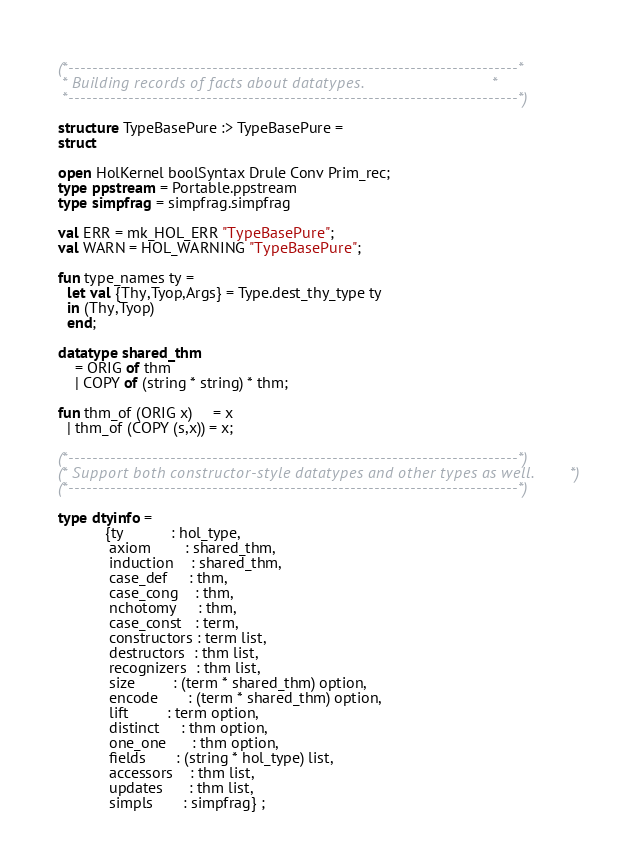Convert code to text. <code><loc_0><loc_0><loc_500><loc_500><_SML_>(*---------------------------------------------------------------------------*
 * Building records of facts about datatypes.                                *
 *---------------------------------------------------------------------------*)

structure TypeBasePure :> TypeBasePure =
struct

open HolKernel boolSyntax Drule Conv Prim_rec;
type ppstream = Portable.ppstream
type simpfrag = simpfrag.simpfrag

val ERR = mk_HOL_ERR "TypeBasePure";
val WARN = HOL_WARNING "TypeBasePure";

fun type_names ty =
  let val {Thy,Tyop,Args} = Type.dest_thy_type ty
  in (Thy,Tyop)
  end;

datatype shared_thm
    = ORIG of thm
    | COPY of (string * string) * thm;

fun thm_of (ORIG x)     = x
  | thm_of (COPY (s,x)) = x;

(*---------------------------------------------------------------------------*)
(* Support both constructor-style datatypes and other types as well.         *)
(*---------------------------------------------------------------------------*)

type dtyinfo =
           {ty           : hol_type,
            axiom        : shared_thm,
            induction    : shared_thm,
            case_def     : thm,
            case_cong    : thm,
            nchotomy     : thm,
            case_const   : term,
            constructors : term list,
            destructors  : thm list,
            recognizers  : thm list,
            size         : (term * shared_thm) option,
            encode       : (term * shared_thm) option,
            lift         : term option,
            distinct     : thm option,
            one_one      : thm option,
            fields       : (string * hol_type) list,
            accessors    : thm list,
            updates      : thm list,
            simpls       : simpfrag} ;
</code> 